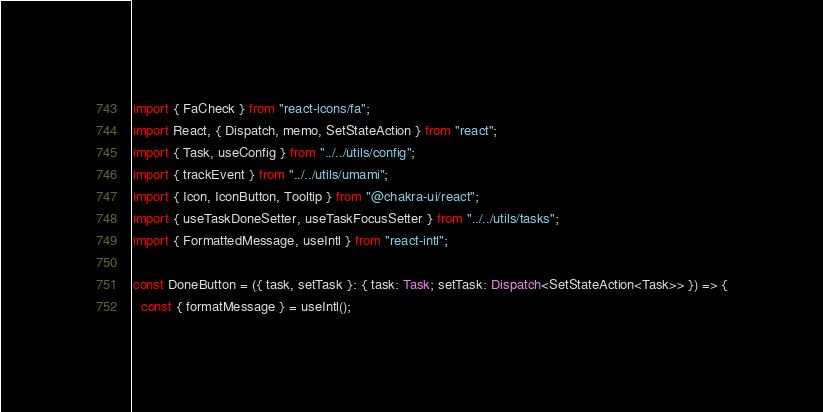Convert code to text. <code><loc_0><loc_0><loc_500><loc_500><_TypeScript_>import { FaCheck } from "react-icons/fa";
import React, { Dispatch, memo, SetStateAction } from "react";
import { Task, useConfig } from "../../utils/config";
import { trackEvent } from "../../utils/umami";
import { Icon, IconButton, Tooltip } from "@chakra-ui/react";
import { useTaskDoneSetter, useTaskFocusSetter } from "../../utils/tasks";
import { FormattedMessage, useIntl } from "react-intl";

const DoneButton = ({ task, setTask }: { task: Task; setTask: Dispatch<SetStateAction<Task>> }) => {
  const { formatMessage } = useIntl();</code> 